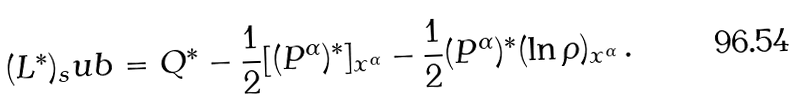<formula> <loc_0><loc_0><loc_500><loc_500>( L ^ { * } ) _ { s } u b = Q ^ { * } - \frac { 1 } { 2 } [ ( P ^ { \alpha } ) ^ { * } ] _ { x ^ { \alpha } } - \frac { 1 } { 2 } ( P ^ { \alpha } ) ^ { * } ( \ln \rho ) _ { x ^ { \alpha } } \, .</formula> 